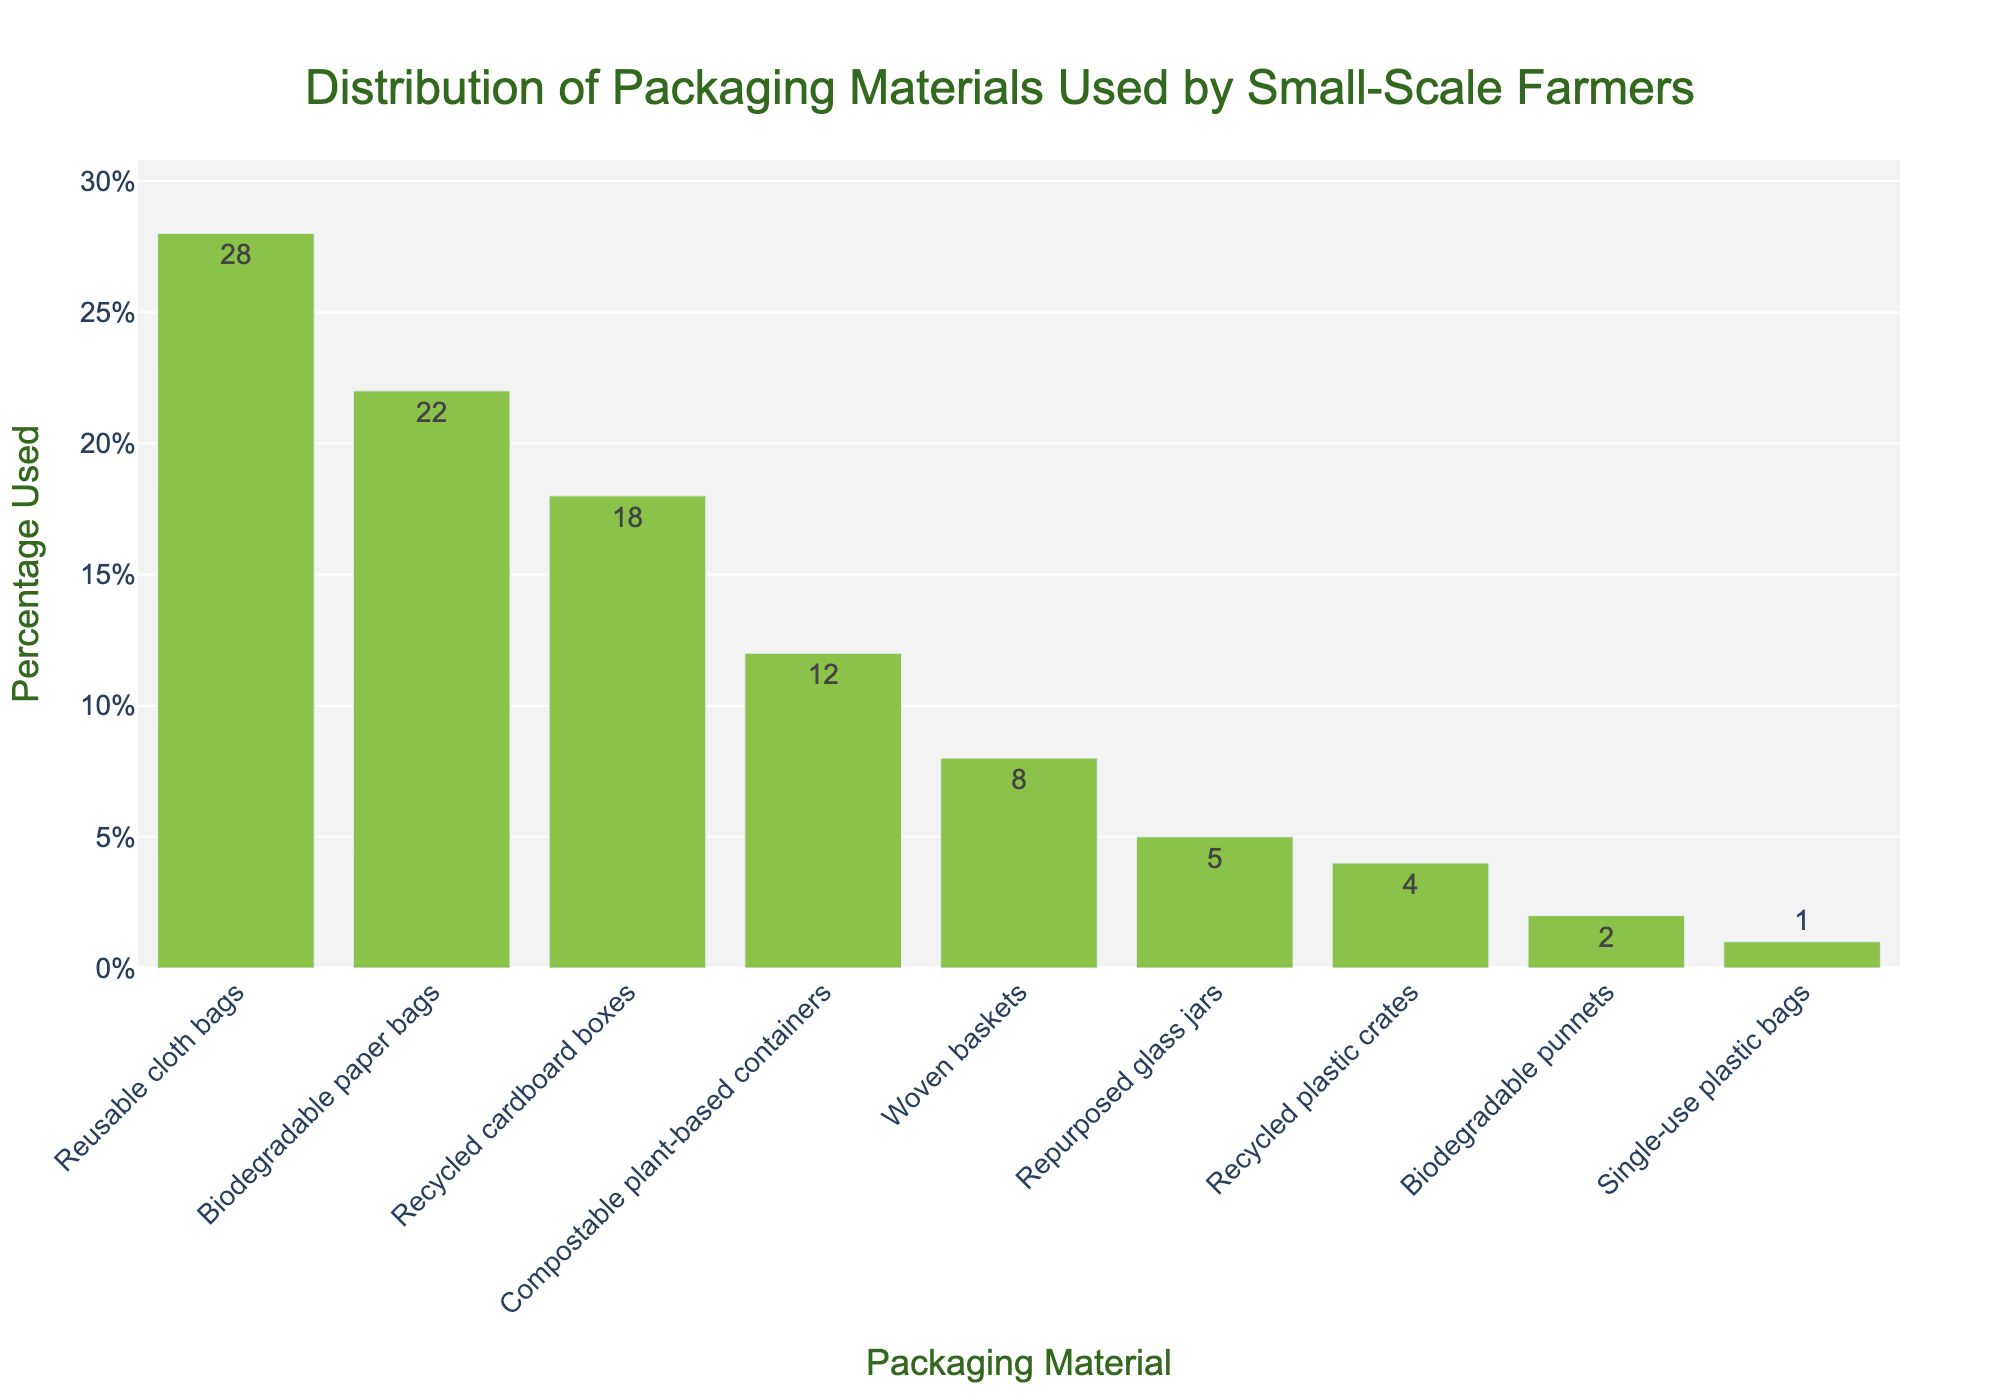What is the most used packaging material by small-scale farmers? The bar with the highest percentage represents the most used packaging material. Reusable cloth bags have the highest value of 28%.
Answer: Reusable cloth bags What percentage of packaging is biodegradable paper bags? Look for the bar labeled "Biodegradable paper bags" and read the percentage value.
Answer: 22% Which packaging material is used the least by small-scale farmers? The bar with the smallest percentage represents the least used packaging material. Single-use plastic bags have the smallest value of 1%.
Answer: Single-use plastic bags How much more popular are reusable cloth bags compared to single-use plastic bags? Subtract the percentage used for single-use plastic bags from the percentage used for reusable cloth bags. 28% - 1% = 27%.
Answer: 27% What is the total percentage of farmers using recycled cardboard boxes and compostable plant-based containers? Add the percentage values for both materials. 18% (Recycled cardboard boxes) + 12% (Compostable plant-based containers) = 30%.
Answer: 30% How many packaging materials have a usage percentage of 10% or higher? Count the bars with percentages of 10% or higher. Reusable cloth bags (28%), Biodegradable paper bags (22%), Recycled cardboard boxes (18%), and Compostable plant-based containers (12%) make a total of 4.
Answer: 4 What is the difference in usage percentage between biodegradable paper bags and repurposed glass jars? Subtract the percentage used for repurposed glass jars from the percentage used for biodegradable paper bags. 22% - 5% = 17%.
Answer: 17% Which packaging materials together make up exactly 50% of the usage? Add the percentages of packaging materials until you reach 50%. Reusable cloth bags (28%) + Biodegradable paper bags (22%) = 50%.
Answer: Reusable cloth bags and Biodegradable paper bags By what factor is the percentage usage of reusable cloth bags higher than single-use plastic bags? Divide the percentage used for reusable cloth bags by the percentage used for single-use plastic bags. 28% / 1% = 28.
Answer: 28 Which packaging material has an 8% usage rate, and what is its color in the bar chart? Identify the bar with an 8% value and note its label and color. Woven baskets have an 8% usage rate, and all bars are colored light green.
Answer: Woven baskets and light green 